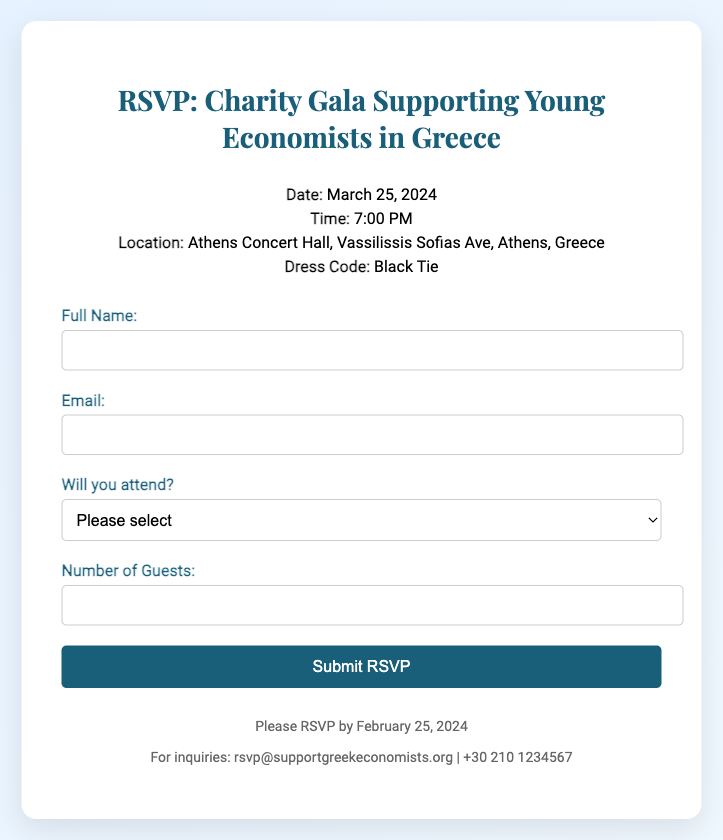What is the date of the gala? The date of the gala is specified in the document.
Answer: March 25, 2024 What time does the event start? The starting time of the event is listed in the document.
Answer: 7:00 PM Where is the location of the event? The document provides the venue's address for the event.
Answer: Athens Concert Hall, Vassilissis Sofias Ave, Athens, Greece What is the dress code for the gala? The dress code for the gala is mentioned in the document.
Answer: Black Tie By when should guests RSVP? The RSVP deadline is indicated in the footer section of the document.
Answer: February 25, 2024 What email should inquiries be sent to? The document specifies an email address for inquiries related to the event.
Answer: rsvp@supportgreekeconomists.org What information is needed to complete the RSVP form? The form requires specific information for RSVP completion, detailed in the document.
Answer: Full Name, Email, Attendance, Number of Guests What is the maximum number of guests one can indicate? While the document indicates a field for guests, it doesn't explicitly limit the number.
Answer: Not specified Will the RSVP form allow for a response if someone cannot attend? The form includes an option for attendance response.
Answer: Yes, “No, I cannot attend” option 